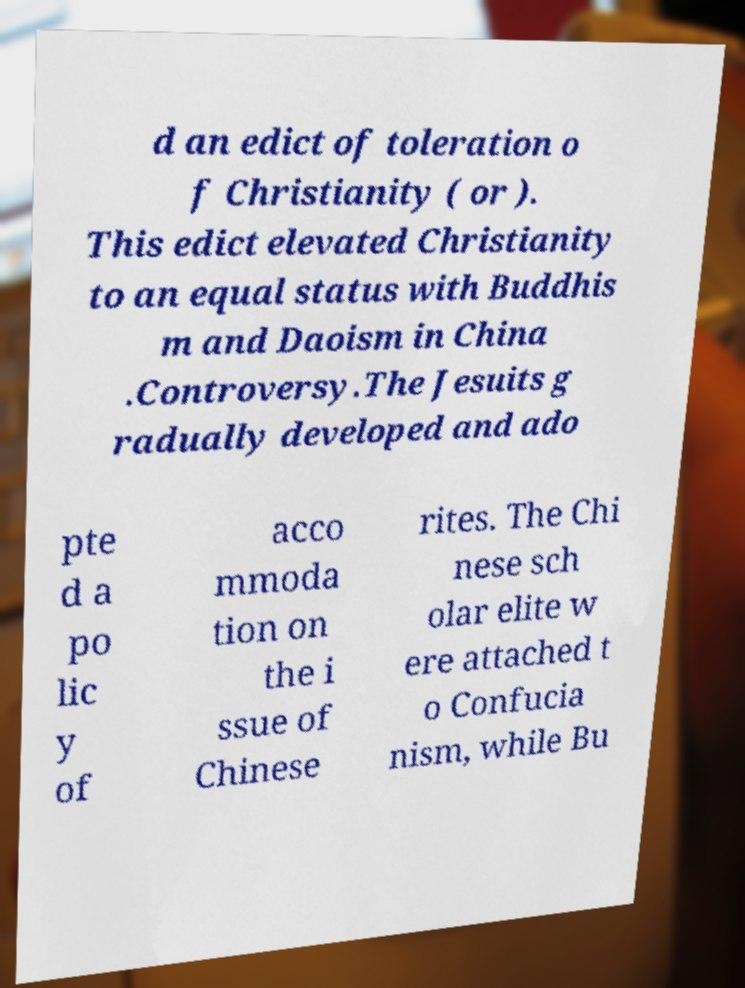Can you read and provide the text displayed in the image?This photo seems to have some interesting text. Can you extract and type it out for me? d an edict of toleration o f Christianity ( or ). This edict elevated Christianity to an equal status with Buddhis m and Daoism in China .Controversy.The Jesuits g radually developed and ado pte d a po lic y of acco mmoda tion on the i ssue of Chinese rites. The Chi nese sch olar elite w ere attached t o Confucia nism, while Bu 